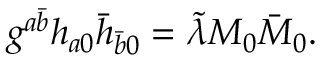<formula> <loc_0><loc_0><loc_500><loc_500>g ^ { a \bar { b } } h _ { a 0 } \bar { h } _ { \bar { b } 0 } = \tilde { \lambda } M _ { 0 } \bar { M } _ { 0 } .</formula> 